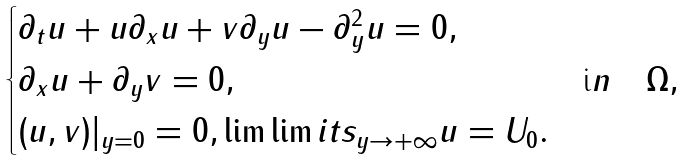<formula> <loc_0><loc_0><loc_500><loc_500>\begin{cases} \partial _ { t } u + u \partial _ { x } u + v \partial _ { y } u - \partial _ { y } ^ { 2 } u = 0 , & \\ \partial _ { x } u + \partial _ { y } v = 0 , & { \mbox i n } \quad \Omega , \\ ( u , v ) | _ { y = 0 } = 0 , \lim \lim i t s _ { y \to + \infty } u = U _ { 0 } . \end{cases}</formula> 